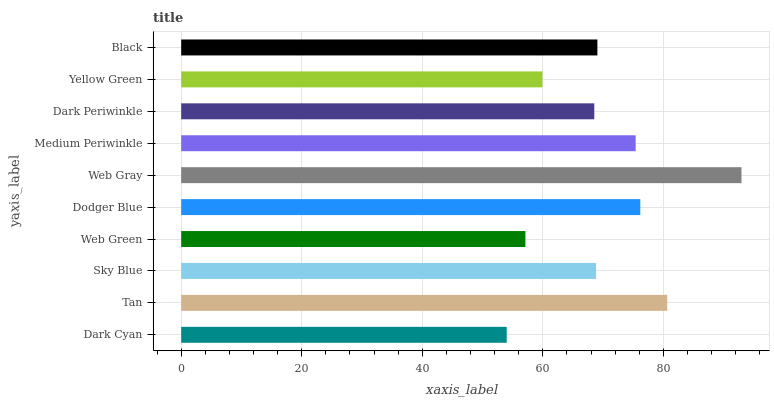Is Dark Cyan the minimum?
Answer yes or no. Yes. Is Web Gray the maximum?
Answer yes or no. Yes. Is Tan the minimum?
Answer yes or no. No. Is Tan the maximum?
Answer yes or no. No. Is Tan greater than Dark Cyan?
Answer yes or no. Yes. Is Dark Cyan less than Tan?
Answer yes or no. Yes. Is Dark Cyan greater than Tan?
Answer yes or no. No. Is Tan less than Dark Cyan?
Answer yes or no. No. Is Black the high median?
Answer yes or no. Yes. Is Sky Blue the low median?
Answer yes or no. Yes. Is Web Gray the high median?
Answer yes or no. No. Is Yellow Green the low median?
Answer yes or no. No. 